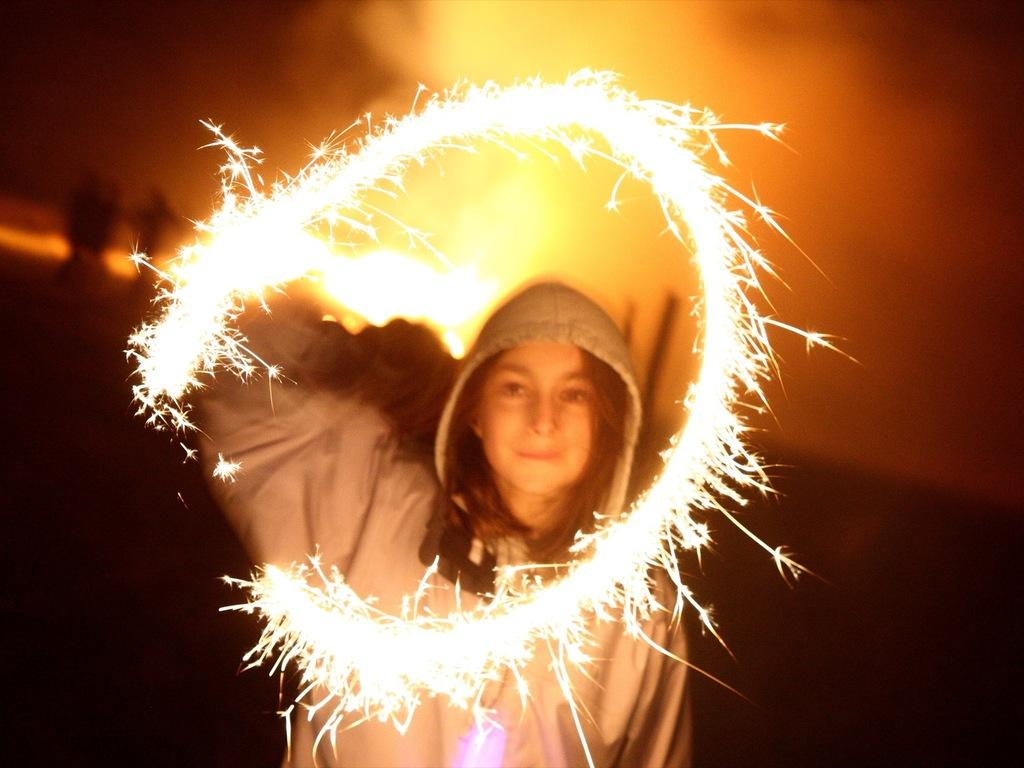Who is the main subject in the image? There is a woman in the image. Where is the woman positioned in the image? The woman is standing in the middle of the image. What is the woman holding in the image? The woman is holding crackers. What is the woman's facial expression in the image? The woman is smiling. What type of soup is the woman eating in the image? There is no soup present in the image; the woman is holding crackers. How many fingers is the woman using to hold the crackers in the image? The image does not show the woman's fingers holding the crackers, so it cannot be determined how many fingers she is using. 